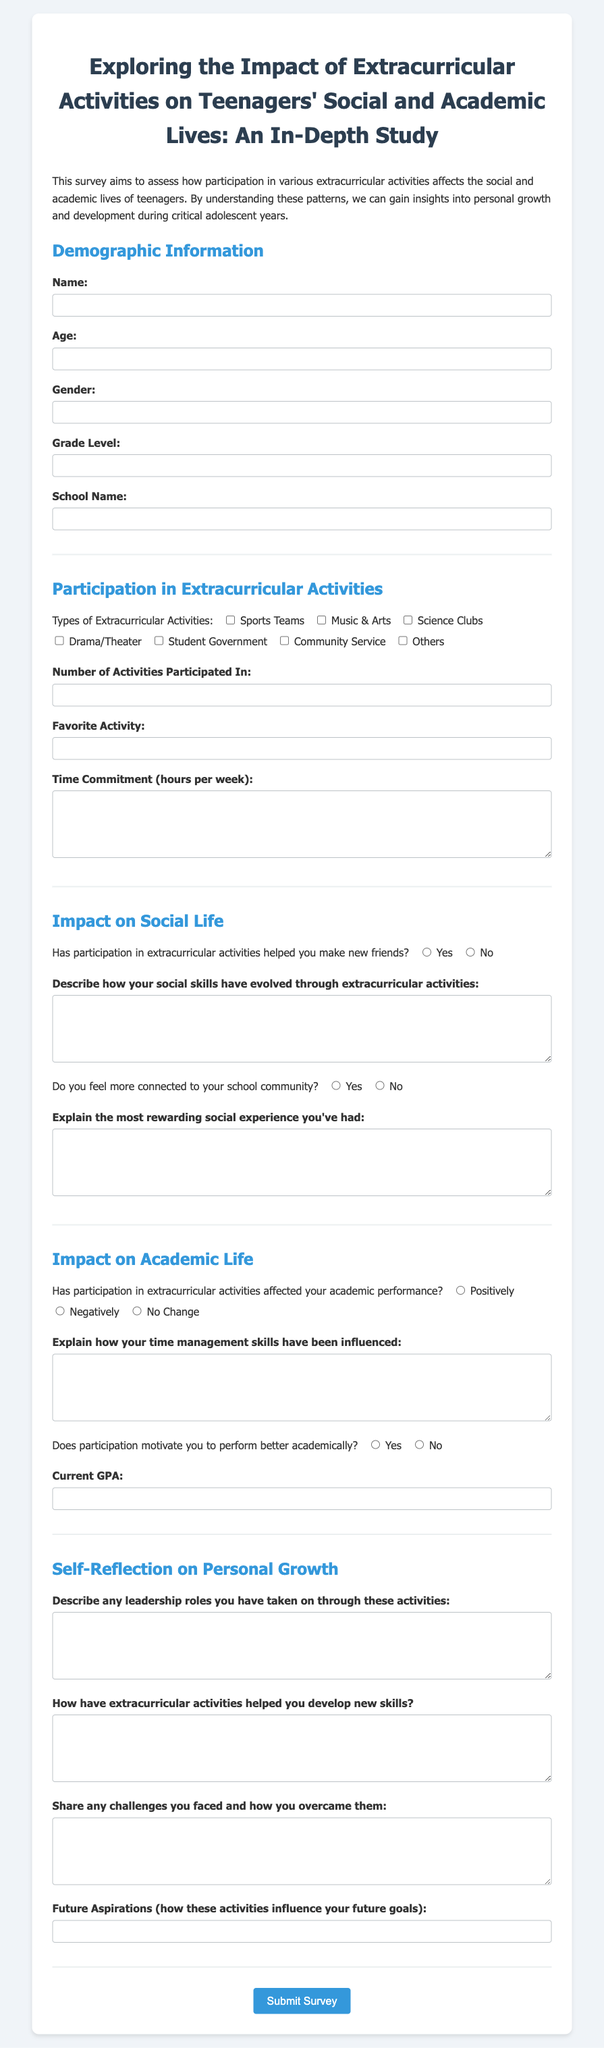What is the title of the survey? The title of the survey is provided in the document header.
Answer: Exploring the Impact of Extracurricular Activities on Teenagers' Social and Academic Lives: An In-Depth Study What section follows the Demographic Information section? The sections in the document are listed sequentially, with the next section coming after Demographic Information.
Answer: Participation in Extracurricular Activities How many types of extracurricular activities are listed? The document contains a checklist indicating different types of activities available for selection.
Answer: 7 What is the maximum GPA that can be entered? The maximum GPA is specified within the input field for current GPA in the academic section.
Answer: 4 What type of feedback is required for time management skills? The document asks for a specific type of descriptive feedback related to time management.
Answer: Explain how your time management skills have been influenced How is the survey submitted? The document includes a button at the end specifically for submitting the survey.
Answer: Submit Survey Has participation in extracurricular activities helped make new friends? The document includes a yes/no question regarding the impact of participation on making new friends.
Answer: Yes or No What is one of the aspects the survey aims to explore? Various aspects are mentioned in the introduction paragraph of the survey.
Answer: Personal growth Which activities can be marked under Sports Teams? Sports Teams is one of the predefined options in the activities checklist section.
Answer: Sports Teams 